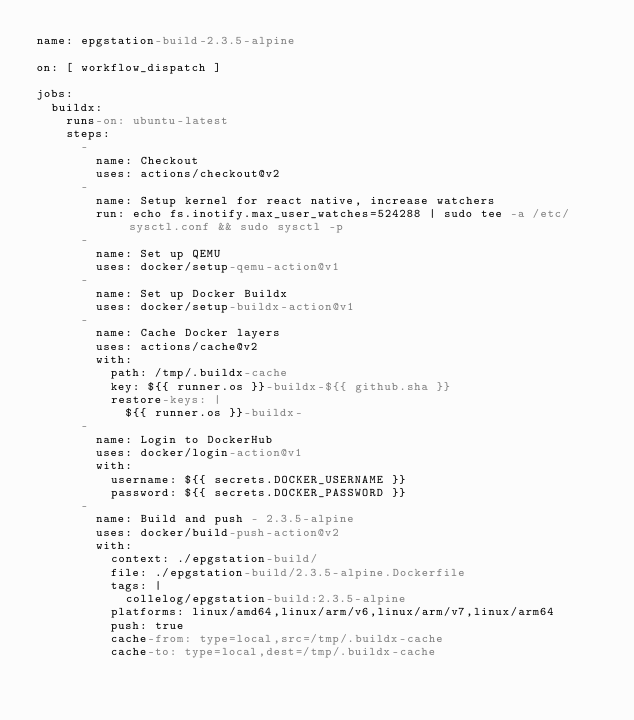Convert code to text. <code><loc_0><loc_0><loc_500><loc_500><_YAML_>name: epgstation-build-2.3.5-alpine

on: [ workflow_dispatch ]

jobs:
  buildx:
    runs-on: ubuntu-latest
    steps:
      -
        name: Checkout
        uses: actions/checkout@v2
      -
        name: Setup kernel for react native, increase watchers
        run: echo fs.inotify.max_user_watches=524288 | sudo tee -a /etc/sysctl.conf && sudo sysctl -p
      -
        name: Set up QEMU
        uses: docker/setup-qemu-action@v1
      -
        name: Set up Docker Buildx
        uses: docker/setup-buildx-action@v1
      -
        name: Cache Docker layers
        uses: actions/cache@v2
        with:
          path: /tmp/.buildx-cache
          key: ${{ runner.os }}-buildx-${{ github.sha }}
          restore-keys: |
            ${{ runner.os }}-buildx-
      -
        name: Login to DockerHub
        uses: docker/login-action@v1 
        with:
          username: ${{ secrets.DOCKER_USERNAME }}
          password: ${{ secrets.DOCKER_PASSWORD }}
      -
        name: Build and push - 2.3.5-alpine
        uses: docker/build-push-action@v2
        with:
          context: ./epgstation-build/
          file: ./epgstation-build/2.3.5-alpine.Dockerfile
          tags: |
            collelog/epgstation-build:2.3.5-alpine
          platforms: linux/amd64,linux/arm/v6,linux/arm/v7,linux/arm64
          push: true
          cache-from: type=local,src=/tmp/.buildx-cache
          cache-to: type=local,dest=/tmp/.buildx-cache
</code> 